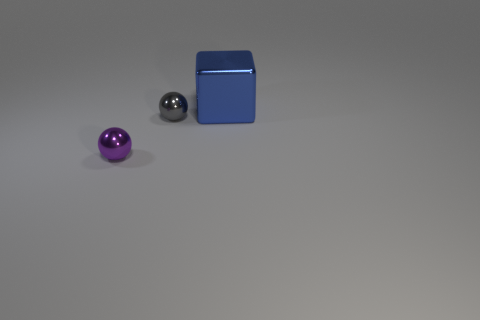Add 3 tiny green matte blocks. How many objects exist? 6 Subtract all cubes. How many objects are left? 2 Subtract all large metallic things. Subtract all tiny gray balls. How many objects are left? 1 Add 2 small purple metallic objects. How many small purple metallic objects are left? 3 Add 2 big yellow spheres. How many big yellow spheres exist? 2 Subtract 1 gray balls. How many objects are left? 2 